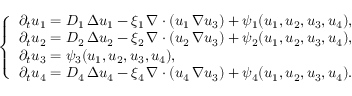Convert formula to latex. <formula><loc_0><loc_0><loc_500><loc_500>\left \{ \begin{array} { l } { \partial _ { t } u _ { 1 } = D _ { 1 } \, \Delta u _ { 1 } - \xi _ { 1 } \, \nabla \cdot ( u _ { 1 } \, \nabla u _ { 3 } ) + \psi _ { 1 } ( u _ { 1 } , u _ { 2 } , u _ { 3 } , u _ { 4 } ) , } \\ { \partial _ { t } u _ { 2 } = D _ { 2 } \, \Delta u _ { 2 } - \xi _ { 2 } \, \nabla \cdot ( u _ { 2 } \, \nabla u _ { 3 } ) + \psi _ { 2 } ( u _ { 1 } , u _ { 2 } , u _ { 3 } , u _ { 4 } ) , } \\ { \partial _ { t } u _ { 3 } = \psi _ { 3 } ( u _ { 1 } , u _ { 2 } , u _ { 3 } , u _ { 4 } ) , } \\ { \partial _ { t } u _ { 4 } = D _ { 4 } \, \Delta u _ { 4 } - \xi _ { 4 } \, \nabla \cdot ( u _ { 4 } \, \nabla u _ { 3 } ) + \psi _ { 4 } ( u _ { 1 } , u _ { 2 } , u _ { 3 } , u _ { 4 } ) . } \end{array}</formula> 